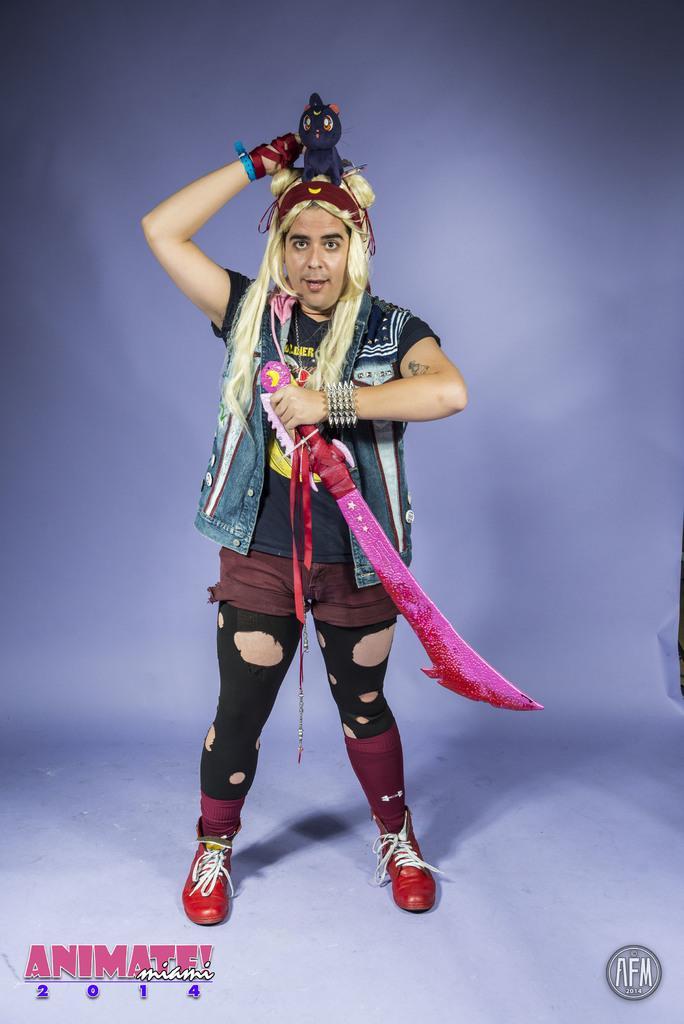In one or two sentences, can you explain what this image depicts? In the image we can see there is a person standing and he is holding sword. He is holding toy in his hand. 